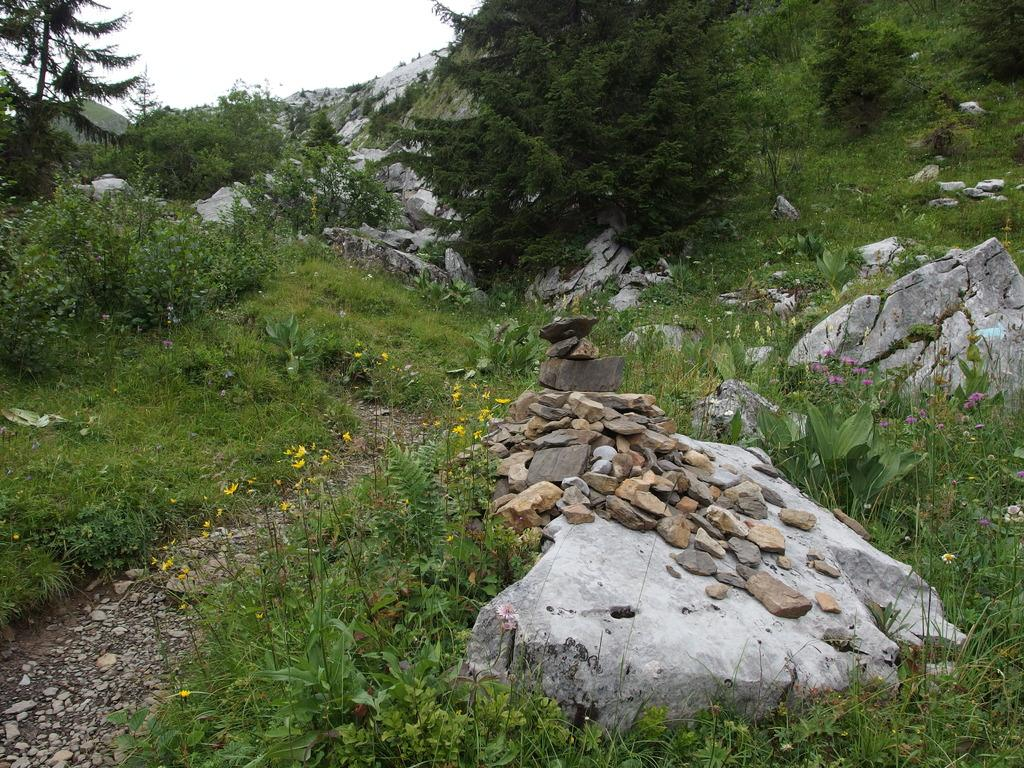What type of landform is in the image? There is a hill in the image. What can be seen on the hill? Trees, plants, grass, and stones are visible on the hill. What is visible at the top of the hill in the image? The sky is visible at the top of the hill in the image. What arithmetic problem is being solved on the hill in the image? There is no arithmetic problem being solved on the hill in the image. Can you see a horn on the hill in the image? There is no horn present on the hill in the image. 